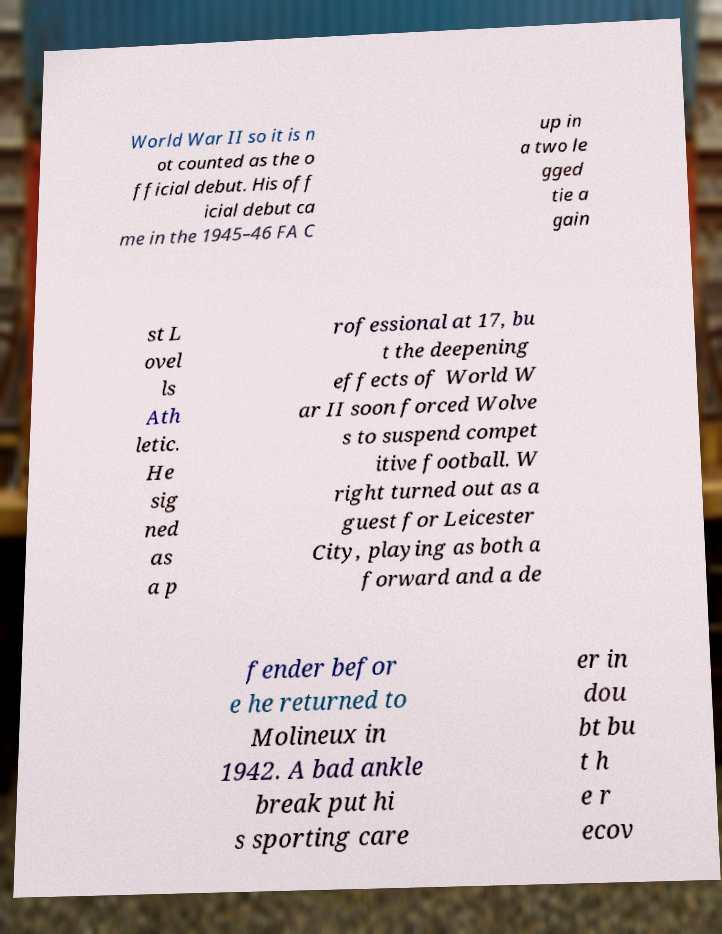Please read and relay the text visible in this image. What does it say? World War II so it is n ot counted as the o fficial debut. His off icial debut ca me in the 1945–46 FA C up in a two le gged tie a gain st L ovel ls Ath letic. He sig ned as a p rofessional at 17, bu t the deepening effects of World W ar II soon forced Wolve s to suspend compet itive football. W right turned out as a guest for Leicester City, playing as both a forward and a de fender befor e he returned to Molineux in 1942. A bad ankle break put hi s sporting care er in dou bt bu t h e r ecov 